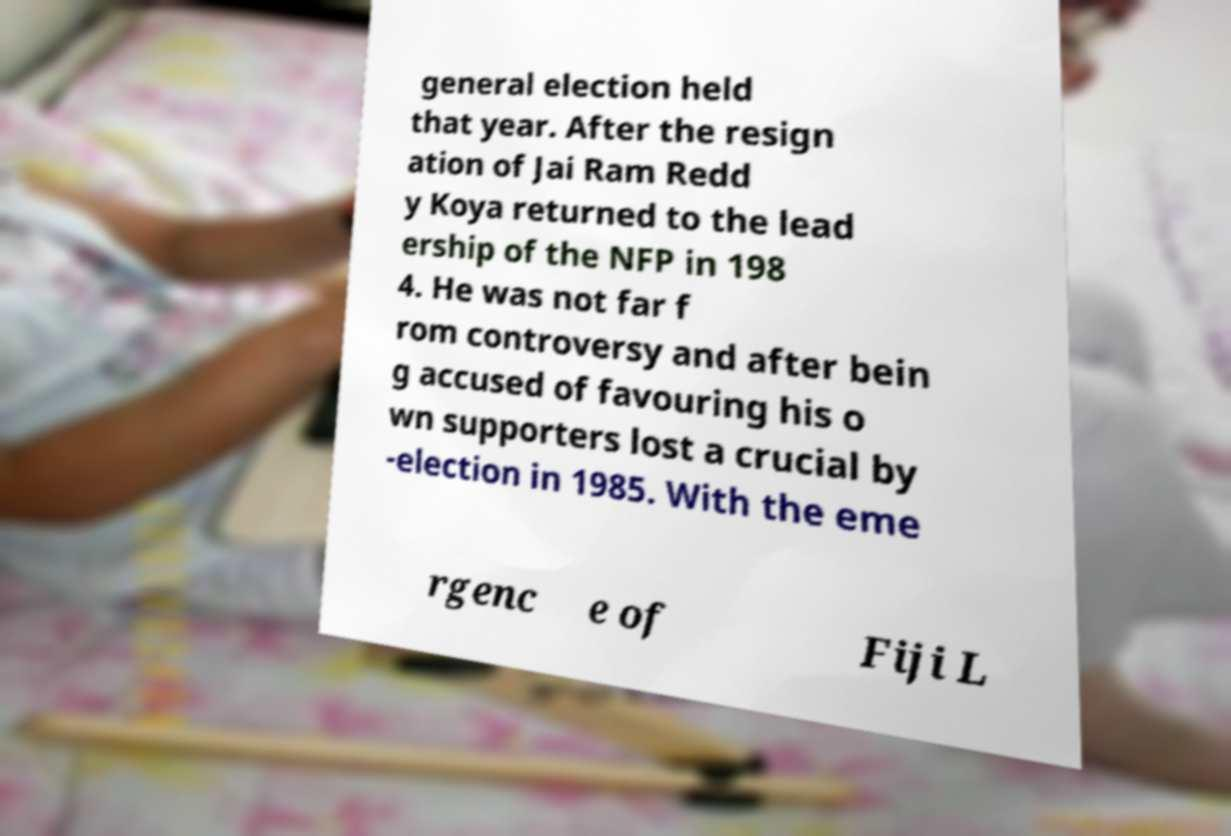What messages or text are displayed in this image? I need them in a readable, typed format. general election held that year. After the resign ation of Jai Ram Redd y Koya returned to the lead ership of the NFP in 198 4. He was not far f rom controversy and after bein g accused of favouring his o wn supporters lost a crucial by -election in 1985. With the eme rgenc e of Fiji L 